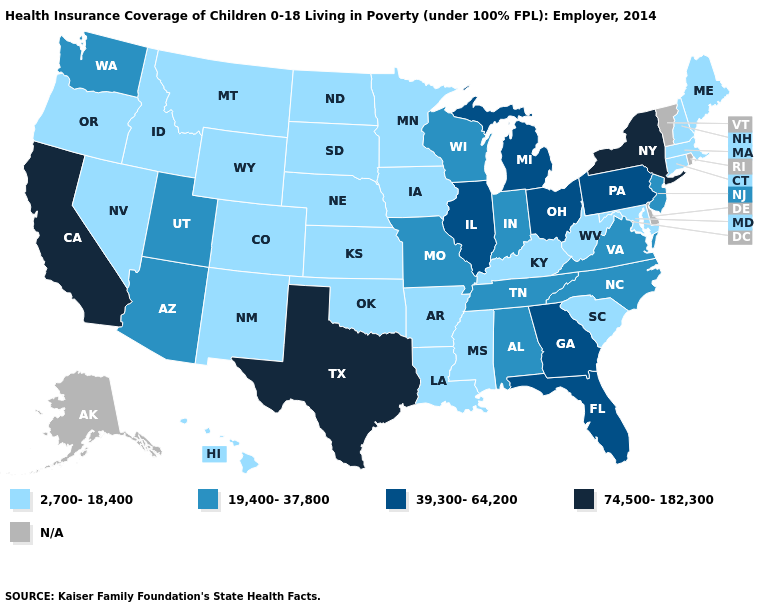Name the states that have a value in the range 74,500-182,300?
Short answer required. California, New York, Texas. Is the legend a continuous bar?
Keep it brief. No. Does Wyoming have the lowest value in the USA?
Quick response, please. Yes. Name the states that have a value in the range N/A?
Keep it brief. Alaska, Delaware, Rhode Island, Vermont. Among the states that border Georgia , does Alabama have the highest value?
Be succinct. No. Name the states that have a value in the range 2,700-18,400?
Keep it brief. Arkansas, Colorado, Connecticut, Hawaii, Idaho, Iowa, Kansas, Kentucky, Louisiana, Maine, Maryland, Massachusetts, Minnesota, Mississippi, Montana, Nebraska, Nevada, New Hampshire, New Mexico, North Dakota, Oklahoma, Oregon, South Carolina, South Dakota, West Virginia, Wyoming. Among the states that border Utah , does Arizona have the lowest value?
Concise answer only. No. Name the states that have a value in the range 2,700-18,400?
Keep it brief. Arkansas, Colorado, Connecticut, Hawaii, Idaho, Iowa, Kansas, Kentucky, Louisiana, Maine, Maryland, Massachusetts, Minnesota, Mississippi, Montana, Nebraska, Nevada, New Hampshire, New Mexico, North Dakota, Oklahoma, Oregon, South Carolina, South Dakota, West Virginia, Wyoming. Which states hav the highest value in the MidWest?
Be succinct. Illinois, Michigan, Ohio. Among the states that border Oregon , which have the highest value?
Keep it brief. California. What is the value of Wyoming?
Keep it brief. 2,700-18,400. Is the legend a continuous bar?
Quick response, please. No. Name the states that have a value in the range N/A?
Short answer required. Alaska, Delaware, Rhode Island, Vermont. 